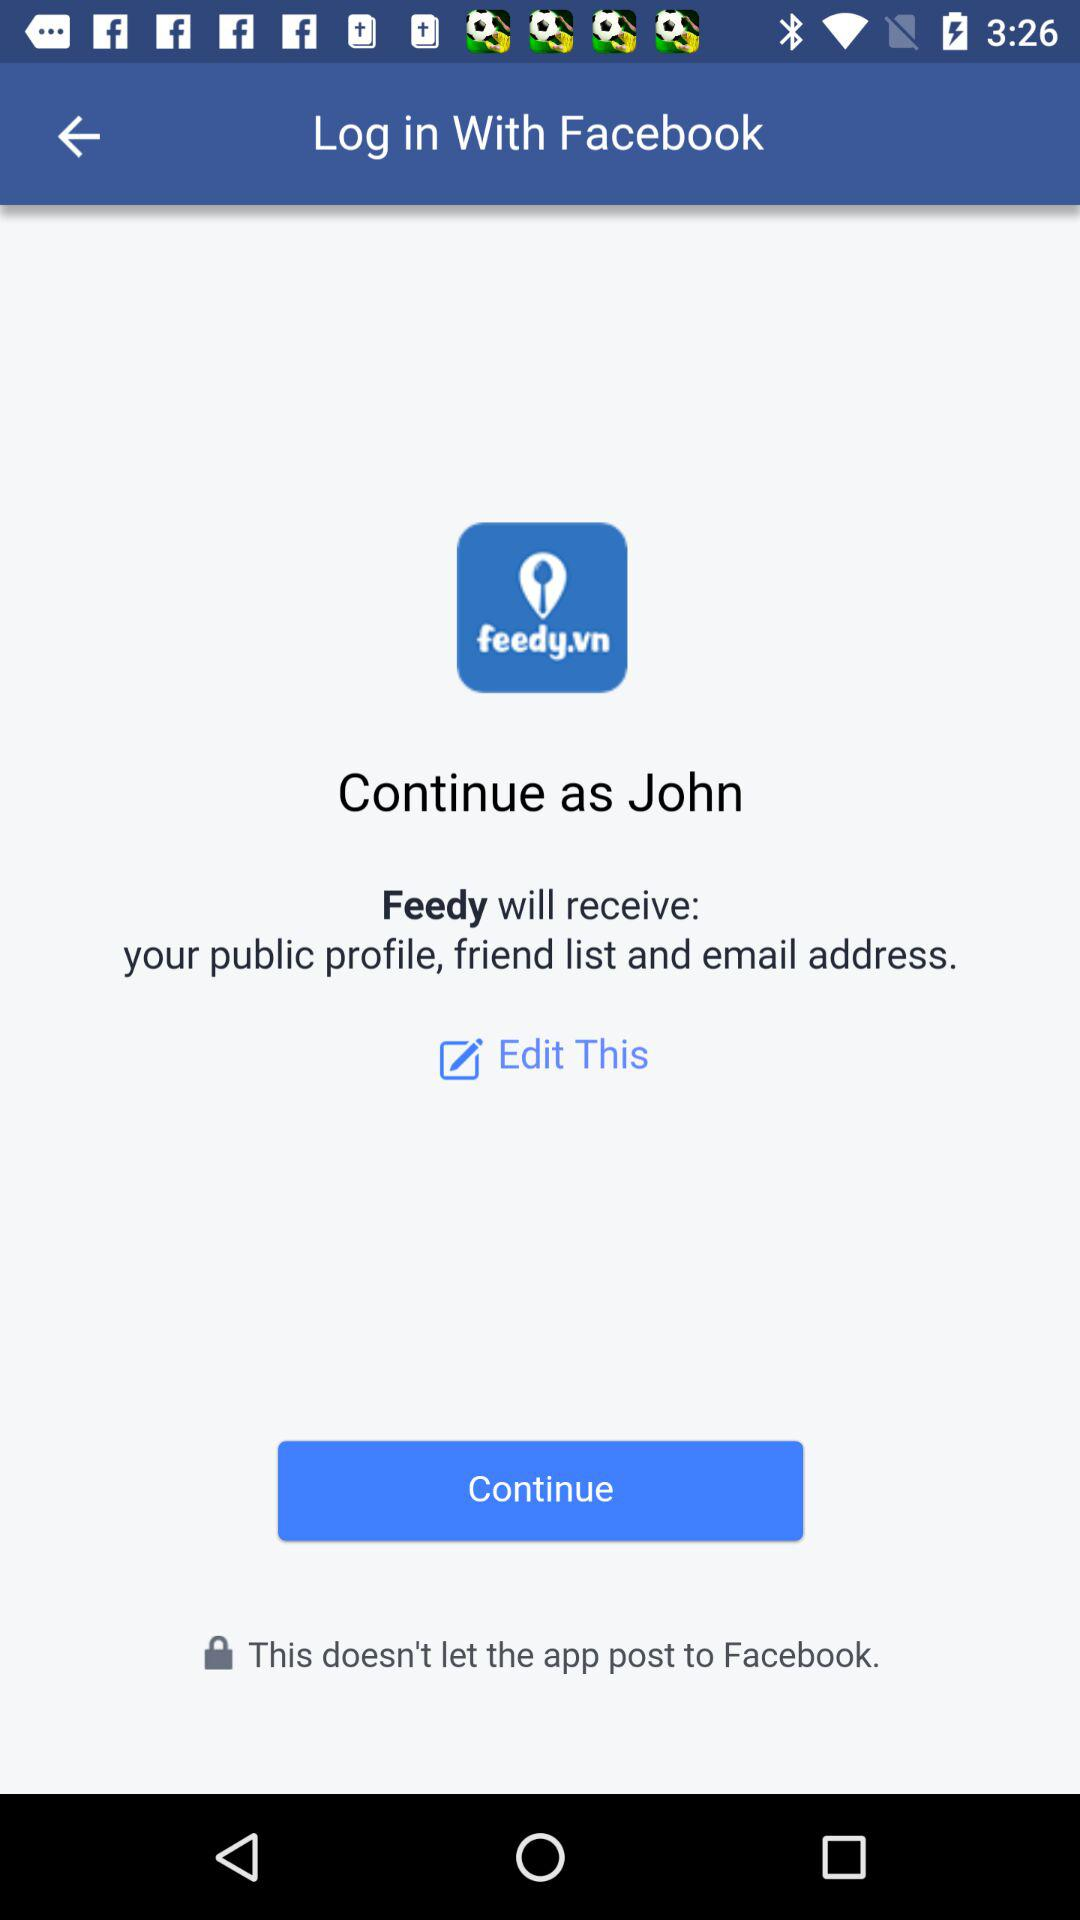Through what application can we log in? You can log in through "Facebook". 